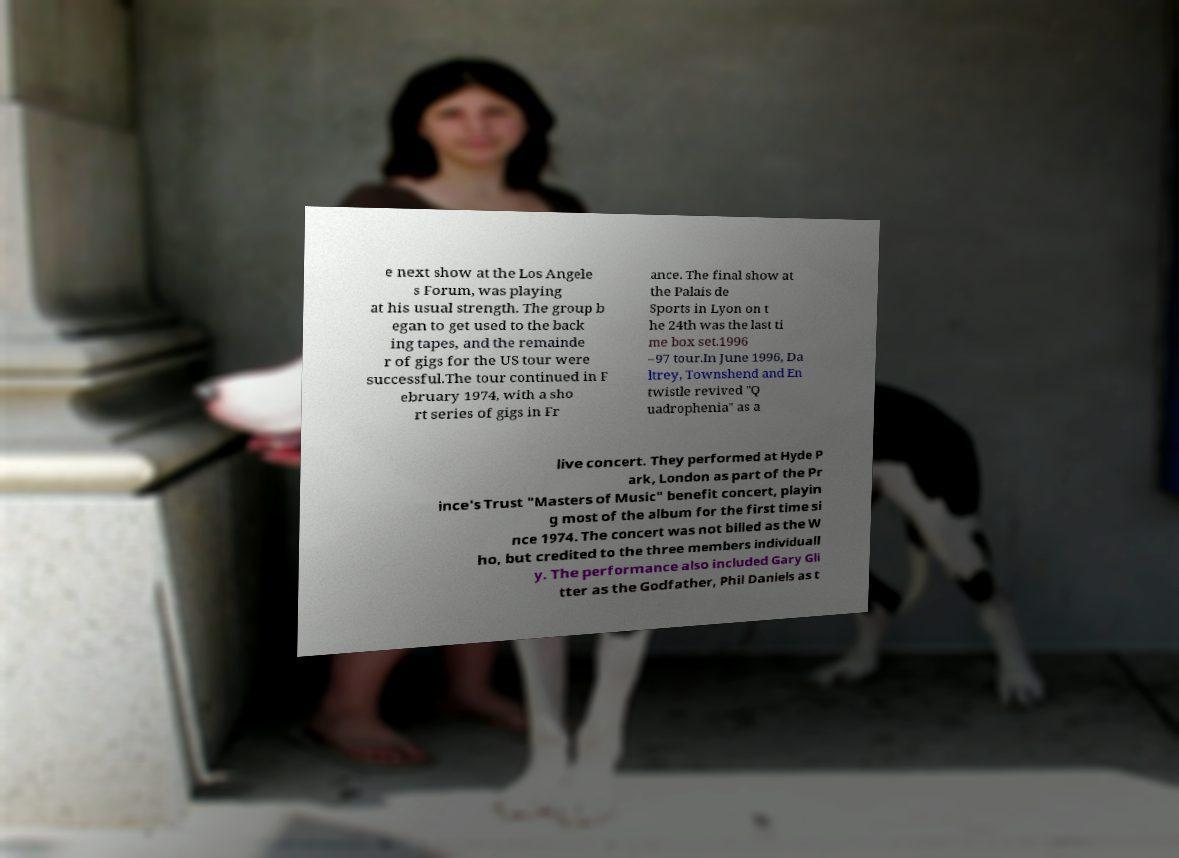I need the written content from this picture converted into text. Can you do that? e next show at the Los Angele s Forum, was playing at his usual strength. The group b egan to get used to the back ing tapes, and the remainde r of gigs for the US tour were successful.The tour continued in F ebruary 1974, with a sho rt series of gigs in Fr ance. The final show at the Palais de Sports in Lyon on t he 24th was the last ti me box set.1996 –97 tour.In June 1996, Da ltrey, Townshend and En twistle revived "Q uadrophenia" as a live concert. They performed at Hyde P ark, London as part of the Pr ince's Trust "Masters of Music" benefit concert, playin g most of the album for the first time si nce 1974. The concert was not billed as the W ho, but credited to the three members individuall y. The performance also included Gary Gli tter as the Godfather, Phil Daniels as t 